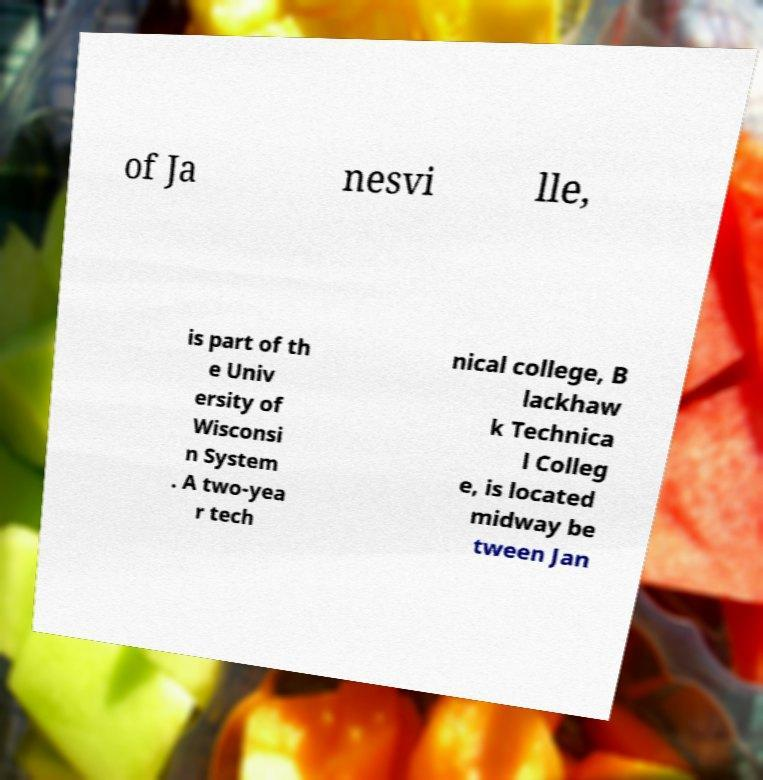There's text embedded in this image that I need extracted. Can you transcribe it verbatim? of Ja nesvi lle, is part of th e Univ ersity of Wisconsi n System . A two-yea r tech nical college, B lackhaw k Technica l Colleg e, is located midway be tween Jan 